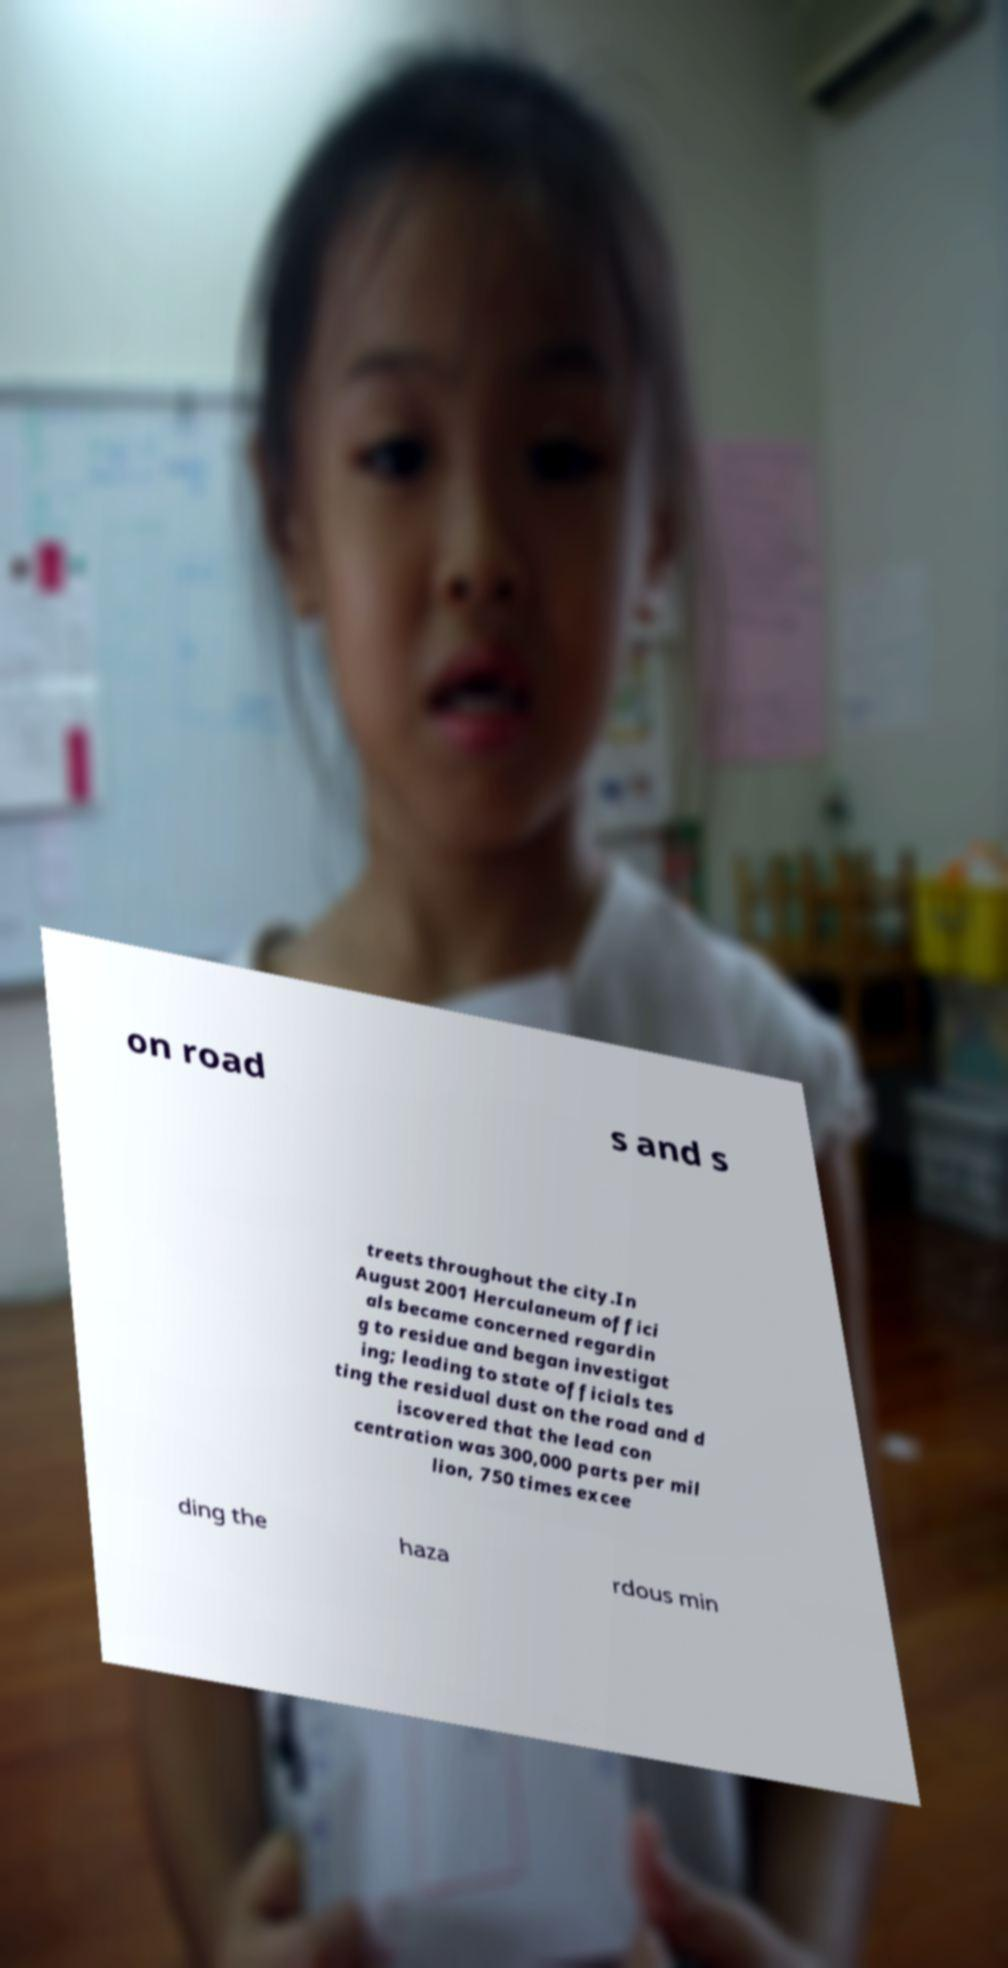For documentation purposes, I need the text within this image transcribed. Could you provide that? on road s and s treets throughout the city.In August 2001 Herculaneum offici als became concerned regardin g to residue and began investigat ing; leading to state officials tes ting the residual dust on the road and d iscovered that the lead con centration was 300,000 parts per mil lion, 750 times excee ding the haza rdous min 